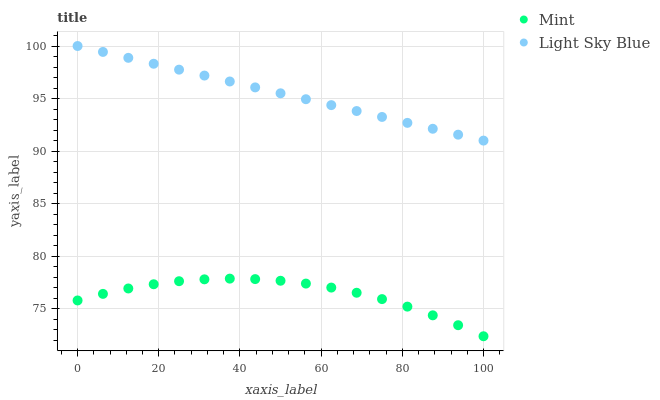Does Mint have the minimum area under the curve?
Answer yes or no. Yes. Does Light Sky Blue have the maximum area under the curve?
Answer yes or no. Yes. Does Mint have the maximum area under the curve?
Answer yes or no. No. Is Light Sky Blue the smoothest?
Answer yes or no. Yes. Is Mint the roughest?
Answer yes or no. Yes. Is Mint the smoothest?
Answer yes or no. No. Does Mint have the lowest value?
Answer yes or no. Yes. Does Light Sky Blue have the highest value?
Answer yes or no. Yes. Does Mint have the highest value?
Answer yes or no. No. Is Mint less than Light Sky Blue?
Answer yes or no. Yes. Is Light Sky Blue greater than Mint?
Answer yes or no. Yes. Does Mint intersect Light Sky Blue?
Answer yes or no. No. 